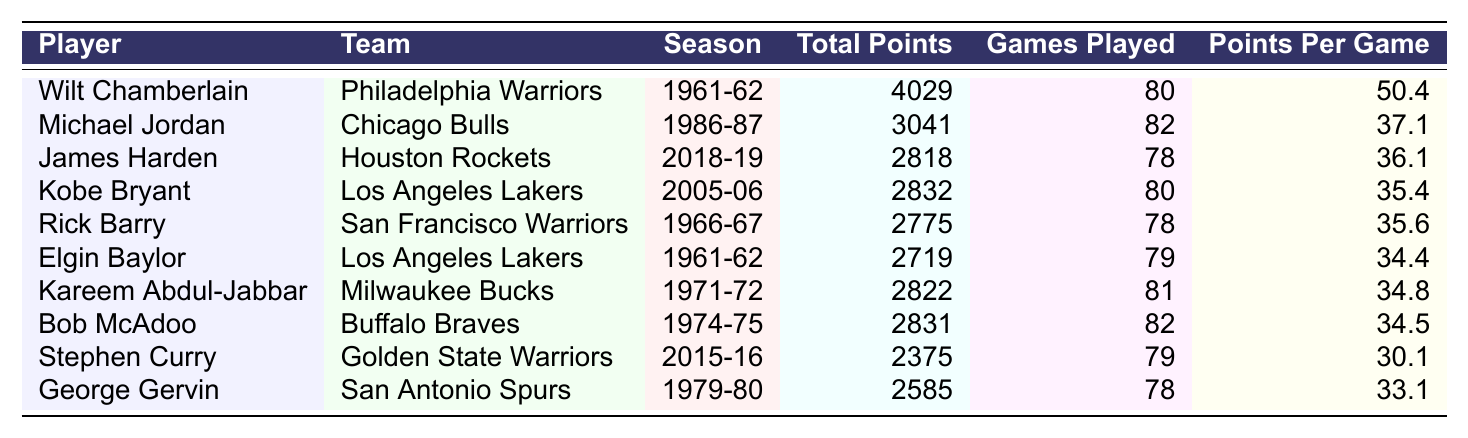What is the total points scored by Wilt Chamberlain in the 1961-62 season? The table shows that Wilt Chamberlain scored a total of 4029 points in the 1961-62 season.
Answer: 4029 Which player has the highest points per game? By looking at the "Points Per Game" column, Wilt Chamberlain has the highest average of 50.4 points per game.
Answer: 50.4 How many games did Michael Jordan play in the 1986-87 season? The table indicates that Michael Jordan played 82 games during the 1986-87 season.
Answer: 82 Who scored more total points, Kobe Bryant or James Harden? From the table, Kobe Bryant scored 2832 total points while James Harden scored 2818 points. Since 2832 > 2818, Kobe Bryant scored more.
Answer: Kobe Bryant What is the average points per game of the top three scorers? The top three scorers are Wilt Chamberlain (50.4), Michael Jordan (37.1), and James Harden (36.1). Their total points per game is 50.4 + 37.1 + 36.1 = 123.6. There are three players, so the average is 123.6 / 3 = 41.2.
Answer: 41.2 Is it true that Rick Barry scored more points than Elgin Baylor? The table shows that Rick Barry scored 2775 points and Elgin Baylor scored 2719 points. Since 2775 > 2719, it is true that Rick Barry scored more points than Elgin Baylor.
Answer: True What is the difference in total points between Kareem Abdul-Jabbar and Bob McAdoo? Kareem Abdul-Jabbar scored 2822 points and Bob McAdoo scored 2831 points. To find the difference: 2831 - 2822 = 9.
Answer: 9 What was Stephen Curry's scoring average in the 2015-16 season? According to the table, Stephen Curry had an average of 30.1 points per game in the 2015-16 season.
Answer: 30.1 Which player had the most games played in a season? The table shows that Michael Jordan played the most games, totaling 82 in the 1986-87 season.
Answer: Michael Jordan Calculate the total points scored by players in the 1961-62 season. The total points in the 1961-62 season are Wilt Chamberlain (4029) and Elgin Baylor (2719). The sum is 4029 + 2719 = 6748.
Answer: 6748 